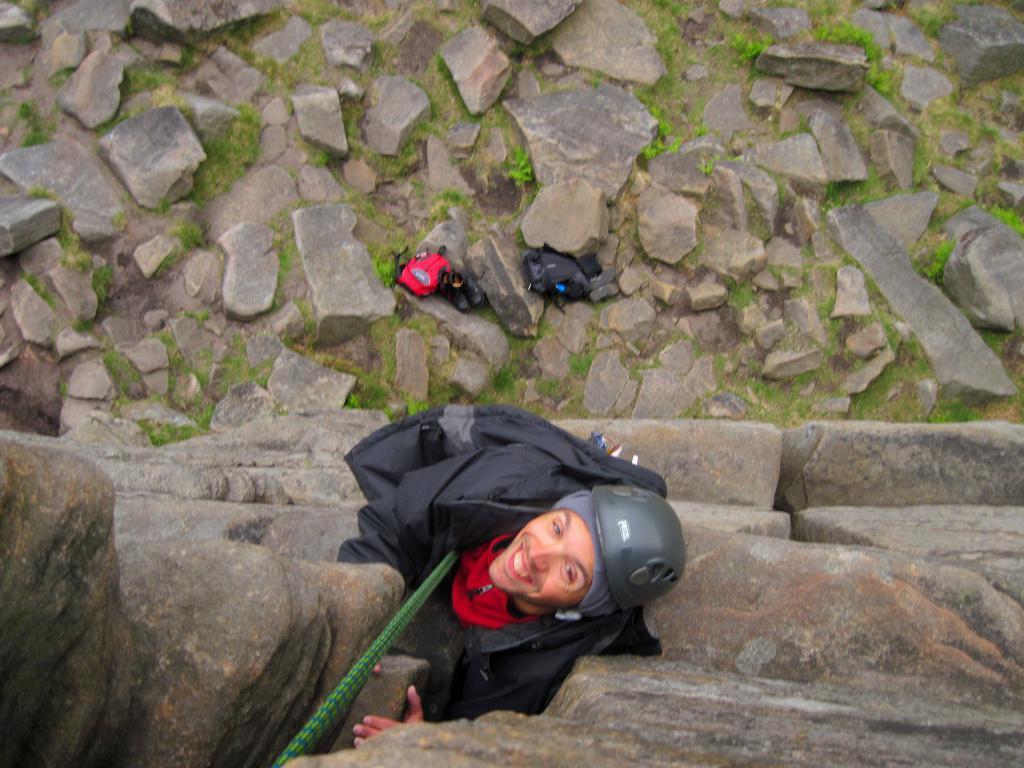Can you describe this image briefly? In this picture we can see a person climbing rocks with the help of rope, down we can see some rocks, grass, bags and shoes. 